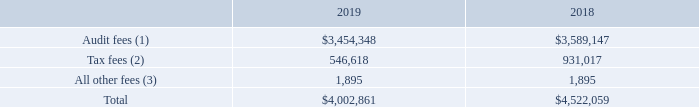Principal Accounting Fees and Services
The following table sets forth fees for services provided by Deloitte & Touche LLP, the member firms of Deloitte Touche Tohmatsu, and their respective affiliates (collectively, ‘‘Deloitte’’) during fiscal 2019 and 2018:
(1) Represents fees for professional services provided in connection with the integrated audit of our annual financial statements and internal control over financial reporting and review of our quarterly financial statements, advice on accounting matters that arose during the audit and audit services provided in connection with other statutory or regulatory filings.
(2) Represents tax compliance and related services.
(3) Represents the annual subscription for access to the Deloitte Accounting Research Tool, which is a searchable on-line accounting database.
What do tax fees represent? Tax compliance and related services. What do all other fees represent? The annual subscription for access to the deloitte accounting research tool, which is a searchable on-line accounting database. What are the types of principal accounting fees and services? Audit fees, tax fees, all other fees. In which year were tax fees larger? 931,017>546,618
Answer: 2018. What was the change in All other fees in 2019 from 2018? 1,895-1,895
Answer: 0. What was the percentage change in All other fees in 2019 from 2018?
Answer scale should be: percent. (1,895-1,895)/1,895
Answer: 0. 